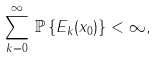<formula> <loc_0><loc_0><loc_500><loc_500>\sum ^ { \infty } _ { k = 0 } \, \mathbb { P } \left \{ E _ { k } ( x _ { 0 } ) \right \} < \infty ,</formula> 